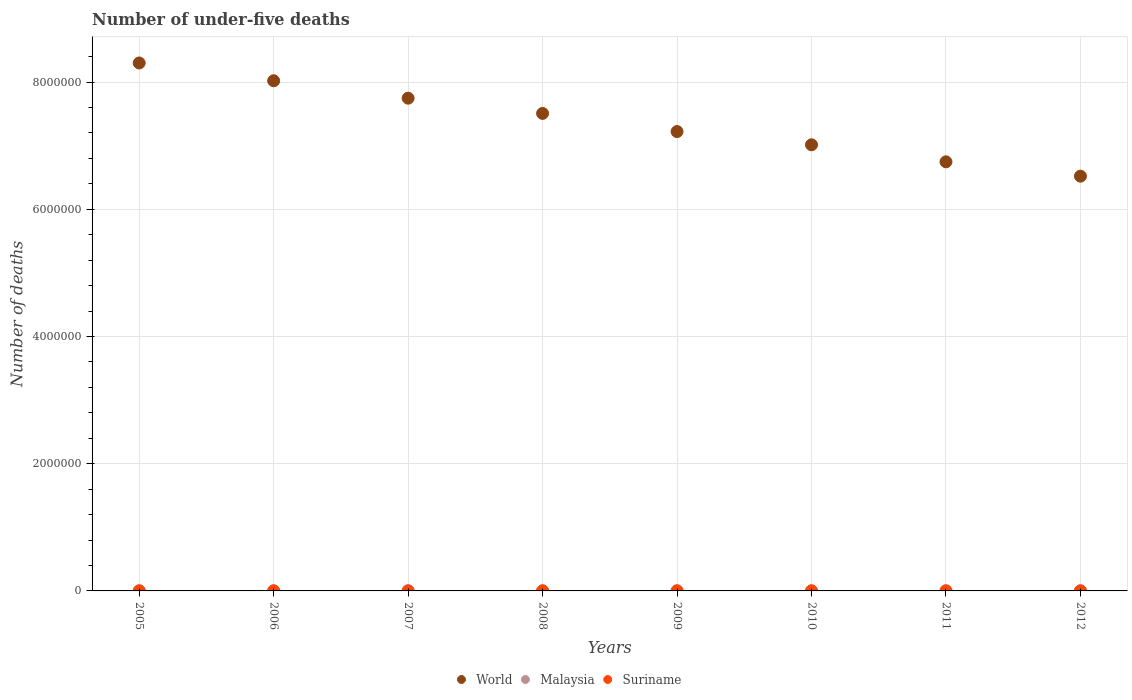Is the number of dotlines equal to the number of legend labels?
Your answer should be very brief. Yes. What is the number of under-five deaths in Suriname in 2006?
Provide a succinct answer. 278. Across all years, what is the maximum number of under-five deaths in Malaysia?
Your response must be concise. 4023. Across all years, what is the minimum number of under-five deaths in World?
Keep it short and to the point. 6.52e+06. In which year was the number of under-five deaths in Malaysia maximum?
Keep it short and to the point. 2005. In which year was the number of under-five deaths in Suriname minimum?
Provide a succinct answer. 2012. What is the total number of under-five deaths in World in the graph?
Your answer should be very brief. 5.91e+07. What is the difference between the number of under-five deaths in World in 2008 and that in 2009?
Provide a succinct answer. 2.85e+05. What is the difference between the number of under-five deaths in Malaysia in 2008 and the number of under-five deaths in Suriname in 2009?
Provide a succinct answer. 3275. What is the average number of under-five deaths in Malaysia per year?
Your answer should be very brief. 3645.88. In the year 2007, what is the difference between the number of under-five deaths in World and number of under-five deaths in Suriname?
Keep it short and to the point. 7.75e+06. What is the ratio of the number of under-five deaths in World in 2006 to that in 2011?
Your response must be concise. 1.19. Is the number of under-five deaths in Suriname in 2005 less than that in 2006?
Provide a succinct answer. No. What is the difference between the highest and the second highest number of under-five deaths in Malaysia?
Keep it short and to the point. 181. In how many years, is the number of under-five deaths in Suriname greater than the average number of under-five deaths in Suriname taken over all years?
Your response must be concise. 4. Is it the case that in every year, the sum of the number of under-five deaths in Suriname and number of under-five deaths in World  is greater than the number of under-five deaths in Malaysia?
Make the answer very short. Yes. Does the number of under-five deaths in Malaysia monotonically increase over the years?
Offer a very short reply. No. Is the number of under-five deaths in Malaysia strictly greater than the number of under-five deaths in World over the years?
Make the answer very short. No. Is the number of under-five deaths in World strictly less than the number of under-five deaths in Malaysia over the years?
Give a very brief answer. No. What is the difference between two consecutive major ticks on the Y-axis?
Make the answer very short. 2.00e+06. Are the values on the major ticks of Y-axis written in scientific E-notation?
Give a very brief answer. No. Does the graph contain any zero values?
Provide a short and direct response. No. Does the graph contain grids?
Your response must be concise. Yes. How are the legend labels stacked?
Your answer should be very brief. Horizontal. What is the title of the graph?
Keep it short and to the point. Number of under-five deaths. Does "Sint Maarten (Dutch part)" appear as one of the legend labels in the graph?
Your response must be concise. No. What is the label or title of the X-axis?
Your response must be concise. Years. What is the label or title of the Y-axis?
Provide a succinct answer. Number of deaths. What is the Number of deaths in World in 2005?
Make the answer very short. 8.30e+06. What is the Number of deaths in Malaysia in 2005?
Offer a terse response. 4023. What is the Number of deaths in Suriname in 2005?
Provide a short and direct response. 289. What is the Number of deaths in World in 2006?
Your response must be concise. 8.02e+06. What is the Number of deaths in Malaysia in 2006?
Give a very brief answer. 3842. What is the Number of deaths in Suriname in 2006?
Give a very brief answer. 278. What is the Number of deaths of World in 2007?
Make the answer very short. 7.75e+06. What is the Number of deaths of Malaysia in 2007?
Offer a terse response. 3651. What is the Number of deaths of Suriname in 2007?
Your response must be concise. 270. What is the Number of deaths in World in 2008?
Offer a terse response. 7.51e+06. What is the Number of deaths of Malaysia in 2008?
Offer a terse response. 3531. What is the Number of deaths in Suriname in 2008?
Offer a very short reply. 262. What is the Number of deaths of World in 2009?
Your answer should be very brief. 7.22e+06. What is the Number of deaths in Malaysia in 2009?
Your answer should be very brief. 3466. What is the Number of deaths of Suriname in 2009?
Offer a terse response. 256. What is the Number of deaths of World in 2010?
Give a very brief answer. 7.01e+06. What is the Number of deaths of Malaysia in 2010?
Provide a succinct answer. 3484. What is the Number of deaths in Suriname in 2010?
Keep it short and to the point. 251. What is the Number of deaths of World in 2011?
Give a very brief answer. 6.75e+06. What is the Number of deaths of Malaysia in 2011?
Make the answer very short. 3539. What is the Number of deaths of Suriname in 2011?
Your answer should be compact. 243. What is the Number of deaths of World in 2012?
Keep it short and to the point. 6.52e+06. What is the Number of deaths in Malaysia in 2012?
Provide a succinct answer. 3631. What is the Number of deaths of Suriname in 2012?
Your response must be concise. 235. Across all years, what is the maximum Number of deaths of World?
Your answer should be compact. 8.30e+06. Across all years, what is the maximum Number of deaths in Malaysia?
Offer a terse response. 4023. Across all years, what is the maximum Number of deaths of Suriname?
Your answer should be compact. 289. Across all years, what is the minimum Number of deaths in World?
Ensure brevity in your answer.  6.52e+06. Across all years, what is the minimum Number of deaths in Malaysia?
Keep it short and to the point. 3466. Across all years, what is the minimum Number of deaths in Suriname?
Make the answer very short. 235. What is the total Number of deaths in World in the graph?
Make the answer very short. 5.91e+07. What is the total Number of deaths of Malaysia in the graph?
Your response must be concise. 2.92e+04. What is the total Number of deaths of Suriname in the graph?
Provide a succinct answer. 2084. What is the difference between the Number of deaths in World in 2005 and that in 2006?
Provide a short and direct response. 2.80e+05. What is the difference between the Number of deaths in Malaysia in 2005 and that in 2006?
Your response must be concise. 181. What is the difference between the Number of deaths in World in 2005 and that in 2007?
Make the answer very short. 5.54e+05. What is the difference between the Number of deaths in Malaysia in 2005 and that in 2007?
Make the answer very short. 372. What is the difference between the Number of deaths of Suriname in 2005 and that in 2007?
Your answer should be compact. 19. What is the difference between the Number of deaths of World in 2005 and that in 2008?
Offer a very short reply. 7.93e+05. What is the difference between the Number of deaths of Malaysia in 2005 and that in 2008?
Your response must be concise. 492. What is the difference between the Number of deaths of Suriname in 2005 and that in 2008?
Your answer should be compact. 27. What is the difference between the Number of deaths in World in 2005 and that in 2009?
Ensure brevity in your answer.  1.08e+06. What is the difference between the Number of deaths of Malaysia in 2005 and that in 2009?
Give a very brief answer. 557. What is the difference between the Number of deaths of World in 2005 and that in 2010?
Provide a succinct answer. 1.29e+06. What is the difference between the Number of deaths of Malaysia in 2005 and that in 2010?
Your response must be concise. 539. What is the difference between the Number of deaths in Suriname in 2005 and that in 2010?
Make the answer very short. 38. What is the difference between the Number of deaths in World in 2005 and that in 2011?
Offer a terse response. 1.55e+06. What is the difference between the Number of deaths of Malaysia in 2005 and that in 2011?
Provide a succinct answer. 484. What is the difference between the Number of deaths in World in 2005 and that in 2012?
Your answer should be compact. 1.78e+06. What is the difference between the Number of deaths of Malaysia in 2005 and that in 2012?
Provide a succinct answer. 392. What is the difference between the Number of deaths in World in 2006 and that in 2007?
Your response must be concise. 2.74e+05. What is the difference between the Number of deaths of Malaysia in 2006 and that in 2007?
Ensure brevity in your answer.  191. What is the difference between the Number of deaths of Suriname in 2006 and that in 2007?
Your response must be concise. 8. What is the difference between the Number of deaths in World in 2006 and that in 2008?
Provide a short and direct response. 5.13e+05. What is the difference between the Number of deaths in Malaysia in 2006 and that in 2008?
Your answer should be compact. 311. What is the difference between the Number of deaths in World in 2006 and that in 2009?
Your answer should be very brief. 7.99e+05. What is the difference between the Number of deaths of Malaysia in 2006 and that in 2009?
Provide a short and direct response. 376. What is the difference between the Number of deaths of Suriname in 2006 and that in 2009?
Give a very brief answer. 22. What is the difference between the Number of deaths in World in 2006 and that in 2010?
Offer a very short reply. 1.01e+06. What is the difference between the Number of deaths in Malaysia in 2006 and that in 2010?
Ensure brevity in your answer.  358. What is the difference between the Number of deaths of World in 2006 and that in 2011?
Offer a very short reply. 1.27e+06. What is the difference between the Number of deaths in Malaysia in 2006 and that in 2011?
Provide a short and direct response. 303. What is the difference between the Number of deaths of Suriname in 2006 and that in 2011?
Keep it short and to the point. 35. What is the difference between the Number of deaths in World in 2006 and that in 2012?
Keep it short and to the point. 1.50e+06. What is the difference between the Number of deaths in Malaysia in 2006 and that in 2012?
Give a very brief answer. 211. What is the difference between the Number of deaths of World in 2007 and that in 2008?
Provide a succinct answer. 2.40e+05. What is the difference between the Number of deaths of Malaysia in 2007 and that in 2008?
Offer a very short reply. 120. What is the difference between the Number of deaths in World in 2007 and that in 2009?
Make the answer very short. 5.25e+05. What is the difference between the Number of deaths of Malaysia in 2007 and that in 2009?
Give a very brief answer. 185. What is the difference between the Number of deaths of Suriname in 2007 and that in 2009?
Your answer should be compact. 14. What is the difference between the Number of deaths in World in 2007 and that in 2010?
Your answer should be very brief. 7.33e+05. What is the difference between the Number of deaths of Malaysia in 2007 and that in 2010?
Your answer should be compact. 167. What is the difference between the Number of deaths in World in 2007 and that in 2011?
Offer a terse response. 1.00e+06. What is the difference between the Number of deaths of Malaysia in 2007 and that in 2011?
Ensure brevity in your answer.  112. What is the difference between the Number of deaths in World in 2007 and that in 2012?
Offer a terse response. 1.23e+06. What is the difference between the Number of deaths of World in 2008 and that in 2009?
Provide a succinct answer. 2.85e+05. What is the difference between the Number of deaths of Malaysia in 2008 and that in 2009?
Give a very brief answer. 65. What is the difference between the Number of deaths in World in 2008 and that in 2010?
Keep it short and to the point. 4.93e+05. What is the difference between the Number of deaths of World in 2008 and that in 2011?
Make the answer very short. 7.61e+05. What is the difference between the Number of deaths in Malaysia in 2008 and that in 2011?
Your response must be concise. -8. What is the difference between the Number of deaths of Suriname in 2008 and that in 2011?
Your answer should be compact. 19. What is the difference between the Number of deaths in World in 2008 and that in 2012?
Offer a terse response. 9.86e+05. What is the difference between the Number of deaths in Malaysia in 2008 and that in 2012?
Provide a short and direct response. -100. What is the difference between the Number of deaths of Suriname in 2008 and that in 2012?
Ensure brevity in your answer.  27. What is the difference between the Number of deaths of World in 2009 and that in 2010?
Your response must be concise. 2.08e+05. What is the difference between the Number of deaths in Malaysia in 2009 and that in 2010?
Provide a succinct answer. -18. What is the difference between the Number of deaths in World in 2009 and that in 2011?
Your answer should be very brief. 4.76e+05. What is the difference between the Number of deaths in Malaysia in 2009 and that in 2011?
Keep it short and to the point. -73. What is the difference between the Number of deaths in Suriname in 2009 and that in 2011?
Provide a short and direct response. 13. What is the difference between the Number of deaths of World in 2009 and that in 2012?
Offer a terse response. 7.01e+05. What is the difference between the Number of deaths of Malaysia in 2009 and that in 2012?
Offer a very short reply. -165. What is the difference between the Number of deaths in Suriname in 2009 and that in 2012?
Keep it short and to the point. 21. What is the difference between the Number of deaths in World in 2010 and that in 2011?
Your response must be concise. 2.68e+05. What is the difference between the Number of deaths of Malaysia in 2010 and that in 2011?
Give a very brief answer. -55. What is the difference between the Number of deaths of Suriname in 2010 and that in 2011?
Your answer should be very brief. 8. What is the difference between the Number of deaths of World in 2010 and that in 2012?
Offer a very short reply. 4.93e+05. What is the difference between the Number of deaths of Malaysia in 2010 and that in 2012?
Your answer should be compact. -147. What is the difference between the Number of deaths of World in 2011 and that in 2012?
Offer a terse response. 2.25e+05. What is the difference between the Number of deaths of Malaysia in 2011 and that in 2012?
Keep it short and to the point. -92. What is the difference between the Number of deaths of World in 2005 and the Number of deaths of Malaysia in 2006?
Keep it short and to the point. 8.30e+06. What is the difference between the Number of deaths in World in 2005 and the Number of deaths in Suriname in 2006?
Your answer should be compact. 8.30e+06. What is the difference between the Number of deaths in Malaysia in 2005 and the Number of deaths in Suriname in 2006?
Ensure brevity in your answer.  3745. What is the difference between the Number of deaths in World in 2005 and the Number of deaths in Malaysia in 2007?
Make the answer very short. 8.30e+06. What is the difference between the Number of deaths in World in 2005 and the Number of deaths in Suriname in 2007?
Give a very brief answer. 8.30e+06. What is the difference between the Number of deaths of Malaysia in 2005 and the Number of deaths of Suriname in 2007?
Your answer should be compact. 3753. What is the difference between the Number of deaths in World in 2005 and the Number of deaths in Malaysia in 2008?
Give a very brief answer. 8.30e+06. What is the difference between the Number of deaths in World in 2005 and the Number of deaths in Suriname in 2008?
Provide a succinct answer. 8.30e+06. What is the difference between the Number of deaths in Malaysia in 2005 and the Number of deaths in Suriname in 2008?
Provide a succinct answer. 3761. What is the difference between the Number of deaths of World in 2005 and the Number of deaths of Malaysia in 2009?
Make the answer very short. 8.30e+06. What is the difference between the Number of deaths of World in 2005 and the Number of deaths of Suriname in 2009?
Ensure brevity in your answer.  8.30e+06. What is the difference between the Number of deaths of Malaysia in 2005 and the Number of deaths of Suriname in 2009?
Offer a very short reply. 3767. What is the difference between the Number of deaths of World in 2005 and the Number of deaths of Malaysia in 2010?
Your response must be concise. 8.30e+06. What is the difference between the Number of deaths in World in 2005 and the Number of deaths in Suriname in 2010?
Your answer should be compact. 8.30e+06. What is the difference between the Number of deaths in Malaysia in 2005 and the Number of deaths in Suriname in 2010?
Your answer should be compact. 3772. What is the difference between the Number of deaths of World in 2005 and the Number of deaths of Malaysia in 2011?
Offer a terse response. 8.30e+06. What is the difference between the Number of deaths of World in 2005 and the Number of deaths of Suriname in 2011?
Ensure brevity in your answer.  8.30e+06. What is the difference between the Number of deaths of Malaysia in 2005 and the Number of deaths of Suriname in 2011?
Your response must be concise. 3780. What is the difference between the Number of deaths of World in 2005 and the Number of deaths of Malaysia in 2012?
Ensure brevity in your answer.  8.30e+06. What is the difference between the Number of deaths in World in 2005 and the Number of deaths in Suriname in 2012?
Make the answer very short. 8.30e+06. What is the difference between the Number of deaths in Malaysia in 2005 and the Number of deaths in Suriname in 2012?
Keep it short and to the point. 3788. What is the difference between the Number of deaths in World in 2006 and the Number of deaths in Malaysia in 2007?
Your answer should be compact. 8.02e+06. What is the difference between the Number of deaths in World in 2006 and the Number of deaths in Suriname in 2007?
Offer a very short reply. 8.02e+06. What is the difference between the Number of deaths in Malaysia in 2006 and the Number of deaths in Suriname in 2007?
Make the answer very short. 3572. What is the difference between the Number of deaths of World in 2006 and the Number of deaths of Malaysia in 2008?
Your answer should be very brief. 8.02e+06. What is the difference between the Number of deaths in World in 2006 and the Number of deaths in Suriname in 2008?
Give a very brief answer. 8.02e+06. What is the difference between the Number of deaths of Malaysia in 2006 and the Number of deaths of Suriname in 2008?
Your response must be concise. 3580. What is the difference between the Number of deaths in World in 2006 and the Number of deaths in Malaysia in 2009?
Offer a very short reply. 8.02e+06. What is the difference between the Number of deaths of World in 2006 and the Number of deaths of Suriname in 2009?
Your answer should be compact. 8.02e+06. What is the difference between the Number of deaths of Malaysia in 2006 and the Number of deaths of Suriname in 2009?
Make the answer very short. 3586. What is the difference between the Number of deaths of World in 2006 and the Number of deaths of Malaysia in 2010?
Provide a short and direct response. 8.02e+06. What is the difference between the Number of deaths of World in 2006 and the Number of deaths of Suriname in 2010?
Provide a short and direct response. 8.02e+06. What is the difference between the Number of deaths of Malaysia in 2006 and the Number of deaths of Suriname in 2010?
Your response must be concise. 3591. What is the difference between the Number of deaths of World in 2006 and the Number of deaths of Malaysia in 2011?
Make the answer very short. 8.02e+06. What is the difference between the Number of deaths of World in 2006 and the Number of deaths of Suriname in 2011?
Your answer should be very brief. 8.02e+06. What is the difference between the Number of deaths in Malaysia in 2006 and the Number of deaths in Suriname in 2011?
Your answer should be compact. 3599. What is the difference between the Number of deaths in World in 2006 and the Number of deaths in Malaysia in 2012?
Offer a terse response. 8.02e+06. What is the difference between the Number of deaths of World in 2006 and the Number of deaths of Suriname in 2012?
Your response must be concise. 8.02e+06. What is the difference between the Number of deaths of Malaysia in 2006 and the Number of deaths of Suriname in 2012?
Your answer should be compact. 3607. What is the difference between the Number of deaths of World in 2007 and the Number of deaths of Malaysia in 2008?
Your response must be concise. 7.74e+06. What is the difference between the Number of deaths in World in 2007 and the Number of deaths in Suriname in 2008?
Your answer should be very brief. 7.75e+06. What is the difference between the Number of deaths in Malaysia in 2007 and the Number of deaths in Suriname in 2008?
Your response must be concise. 3389. What is the difference between the Number of deaths of World in 2007 and the Number of deaths of Malaysia in 2009?
Ensure brevity in your answer.  7.74e+06. What is the difference between the Number of deaths of World in 2007 and the Number of deaths of Suriname in 2009?
Your answer should be very brief. 7.75e+06. What is the difference between the Number of deaths of Malaysia in 2007 and the Number of deaths of Suriname in 2009?
Offer a terse response. 3395. What is the difference between the Number of deaths of World in 2007 and the Number of deaths of Malaysia in 2010?
Provide a succinct answer. 7.74e+06. What is the difference between the Number of deaths in World in 2007 and the Number of deaths in Suriname in 2010?
Your answer should be compact. 7.75e+06. What is the difference between the Number of deaths in Malaysia in 2007 and the Number of deaths in Suriname in 2010?
Make the answer very short. 3400. What is the difference between the Number of deaths in World in 2007 and the Number of deaths in Malaysia in 2011?
Your answer should be compact. 7.74e+06. What is the difference between the Number of deaths in World in 2007 and the Number of deaths in Suriname in 2011?
Give a very brief answer. 7.75e+06. What is the difference between the Number of deaths in Malaysia in 2007 and the Number of deaths in Suriname in 2011?
Give a very brief answer. 3408. What is the difference between the Number of deaths of World in 2007 and the Number of deaths of Malaysia in 2012?
Your answer should be very brief. 7.74e+06. What is the difference between the Number of deaths in World in 2007 and the Number of deaths in Suriname in 2012?
Keep it short and to the point. 7.75e+06. What is the difference between the Number of deaths of Malaysia in 2007 and the Number of deaths of Suriname in 2012?
Give a very brief answer. 3416. What is the difference between the Number of deaths of World in 2008 and the Number of deaths of Malaysia in 2009?
Offer a very short reply. 7.50e+06. What is the difference between the Number of deaths of World in 2008 and the Number of deaths of Suriname in 2009?
Your response must be concise. 7.51e+06. What is the difference between the Number of deaths of Malaysia in 2008 and the Number of deaths of Suriname in 2009?
Your answer should be compact. 3275. What is the difference between the Number of deaths in World in 2008 and the Number of deaths in Malaysia in 2010?
Make the answer very short. 7.50e+06. What is the difference between the Number of deaths of World in 2008 and the Number of deaths of Suriname in 2010?
Your response must be concise. 7.51e+06. What is the difference between the Number of deaths of Malaysia in 2008 and the Number of deaths of Suriname in 2010?
Make the answer very short. 3280. What is the difference between the Number of deaths in World in 2008 and the Number of deaths in Malaysia in 2011?
Make the answer very short. 7.50e+06. What is the difference between the Number of deaths of World in 2008 and the Number of deaths of Suriname in 2011?
Give a very brief answer. 7.51e+06. What is the difference between the Number of deaths in Malaysia in 2008 and the Number of deaths in Suriname in 2011?
Provide a succinct answer. 3288. What is the difference between the Number of deaths of World in 2008 and the Number of deaths of Malaysia in 2012?
Your response must be concise. 7.50e+06. What is the difference between the Number of deaths in World in 2008 and the Number of deaths in Suriname in 2012?
Your answer should be very brief. 7.51e+06. What is the difference between the Number of deaths in Malaysia in 2008 and the Number of deaths in Suriname in 2012?
Offer a very short reply. 3296. What is the difference between the Number of deaths in World in 2009 and the Number of deaths in Malaysia in 2010?
Give a very brief answer. 7.22e+06. What is the difference between the Number of deaths of World in 2009 and the Number of deaths of Suriname in 2010?
Your answer should be compact. 7.22e+06. What is the difference between the Number of deaths in Malaysia in 2009 and the Number of deaths in Suriname in 2010?
Offer a terse response. 3215. What is the difference between the Number of deaths of World in 2009 and the Number of deaths of Malaysia in 2011?
Keep it short and to the point. 7.22e+06. What is the difference between the Number of deaths of World in 2009 and the Number of deaths of Suriname in 2011?
Keep it short and to the point. 7.22e+06. What is the difference between the Number of deaths of Malaysia in 2009 and the Number of deaths of Suriname in 2011?
Your answer should be compact. 3223. What is the difference between the Number of deaths of World in 2009 and the Number of deaths of Malaysia in 2012?
Offer a terse response. 7.22e+06. What is the difference between the Number of deaths in World in 2009 and the Number of deaths in Suriname in 2012?
Provide a short and direct response. 7.22e+06. What is the difference between the Number of deaths in Malaysia in 2009 and the Number of deaths in Suriname in 2012?
Offer a very short reply. 3231. What is the difference between the Number of deaths in World in 2010 and the Number of deaths in Malaysia in 2011?
Make the answer very short. 7.01e+06. What is the difference between the Number of deaths of World in 2010 and the Number of deaths of Suriname in 2011?
Provide a succinct answer. 7.01e+06. What is the difference between the Number of deaths in Malaysia in 2010 and the Number of deaths in Suriname in 2011?
Offer a very short reply. 3241. What is the difference between the Number of deaths in World in 2010 and the Number of deaths in Malaysia in 2012?
Offer a terse response. 7.01e+06. What is the difference between the Number of deaths in World in 2010 and the Number of deaths in Suriname in 2012?
Ensure brevity in your answer.  7.01e+06. What is the difference between the Number of deaths in Malaysia in 2010 and the Number of deaths in Suriname in 2012?
Provide a short and direct response. 3249. What is the difference between the Number of deaths in World in 2011 and the Number of deaths in Malaysia in 2012?
Provide a succinct answer. 6.74e+06. What is the difference between the Number of deaths in World in 2011 and the Number of deaths in Suriname in 2012?
Give a very brief answer. 6.75e+06. What is the difference between the Number of deaths in Malaysia in 2011 and the Number of deaths in Suriname in 2012?
Keep it short and to the point. 3304. What is the average Number of deaths in World per year?
Provide a short and direct response. 7.38e+06. What is the average Number of deaths in Malaysia per year?
Provide a succinct answer. 3645.88. What is the average Number of deaths in Suriname per year?
Provide a succinct answer. 260.5. In the year 2005, what is the difference between the Number of deaths of World and Number of deaths of Malaysia?
Provide a succinct answer. 8.30e+06. In the year 2005, what is the difference between the Number of deaths in World and Number of deaths in Suriname?
Provide a short and direct response. 8.30e+06. In the year 2005, what is the difference between the Number of deaths of Malaysia and Number of deaths of Suriname?
Your answer should be compact. 3734. In the year 2006, what is the difference between the Number of deaths in World and Number of deaths in Malaysia?
Your answer should be very brief. 8.02e+06. In the year 2006, what is the difference between the Number of deaths in World and Number of deaths in Suriname?
Your answer should be very brief. 8.02e+06. In the year 2006, what is the difference between the Number of deaths of Malaysia and Number of deaths of Suriname?
Give a very brief answer. 3564. In the year 2007, what is the difference between the Number of deaths of World and Number of deaths of Malaysia?
Offer a very short reply. 7.74e+06. In the year 2007, what is the difference between the Number of deaths of World and Number of deaths of Suriname?
Give a very brief answer. 7.75e+06. In the year 2007, what is the difference between the Number of deaths of Malaysia and Number of deaths of Suriname?
Keep it short and to the point. 3381. In the year 2008, what is the difference between the Number of deaths in World and Number of deaths in Malaysia?
Offer a terse response. 7.50e+06. In the year 2008, what is the difference between the Number of deaths in World and Number of deaths in Suriname?
Give a very brief answer. 7.51e+06. In the year 2008, what is the difference between the Number of deaths of Malaysia and Number of deaths of Suriname?
Offer a terse response. 3269. In the year 2009, what is the difference between the Number of deaths in World and Number of deaths in Malaysia?
Your answer should be compact. 7.22e+06. In the year 2009, what is the difference between the Number of deaths of World and Number of deaths of Suriname?
Keep it short and to the point. 7.22e+06. In the year 2009, what is the difference between the Number of deaths in Malaysia and Number of deaths in Suriname?
Make the answer very short. 3210. In the year 2010, what is the difference between the Number of deaths of World and Number of deaths of Malaysia?
Offer a terse response. 7.01e+06. In the year 2010, what is the difference between the Number of deaths in World and Number of deaths in Suriname?
Give a very brief answer. 7.01e+06. In the year 2010, what is the difference between the Number of deaths in Malaysia and Number of deaths in Suriname?
Give a very brief answer. 3233. In the year 2011, what is the difference between the Number of deaths in World and Number of deaths in Malaysia?
Keep it short and to the point. 6.74e+06. In the year 2011, what is the difference between the Number of deaths in World and Number of deaths in Suriname?
Keep it short and to the point. 6.75e+06. In the year 2011, what is the difference between the Number of deaths in Malaysia and Number of deaths in Suriname?
Make the answer very short. 3296. In the year 2012, what is the difference between the Number of deaths of World and Number of deaths of Malaysia?
Keep it short and to the point. 6.52e+06. In the year 2012, what is the difference between the Number of deaths of World and Number of deaths of Suriname?
Keep it short and to the point. 6.52e+06. In the year 2012, what is the difference between the Number of deaths in Malaysia and Number of deaths in Suriname?
Offer a very short reply. 3396. What is the ratio of the Number of deaths in World in 2005 to that in 2006?
Ensure brevity in your answer.  1.03. What is the ratio of the Number of deaths of Malaysia in 2005 to that in 2006?
Make the answer very short. 1.05. What is the ratio of the Number of deaths in Suriname in 2005 to that in 2006?
Keep it short and to the point. 1.04. What is the ratio of the Number of deaths of World in 2005 to that in 2007?
Offer a very short reply. 1.07. What is the ratio of the Number of deaths of Malaysia in 2005 to that in 2007?
Your response must be concise. 1.1. What is the ratio of the Number of deaths in Suriname in 2005 to that in 2007?
Your answer should be compact. 1.07. What is the ratio of the Number of deaths in World in 2005 to that in 2008?
Keep it short and to the point. 1.11. What is the ratio of the Number of deaths in Malaysia in 2005 to that in 2008?
Give a very brief answer. 1.14. What is the ratio of the Number of deaths of Suriname in 2005 to that in 2008?
Ensure brevity in your answer.  1.1. What is the ratio of the Number of deaths in World in 2005 to that in 2009?
Ensure brevity in your answer.  1.15. What is the ratio of the Number of deaths in Malaysia in 2005 to that in 2009?
Keep it short and to the point. 1.16. What is the ratio of the Number of deaths in Suriname in 2005 to that in 2009?
Provide a succinct answer. 1.13. What is the ratio of the Number of deaths in World in 2005 to that in 2010?
Your answer should be compact. 1.18. What is the ratio of the Number of deaths of Malaysia in 2005 to that in 2010?
Keep it short and to the point. 1.15. What is the ratio of the Number of deaths in Suriname in 2005 to that in 2010?
Offer a very short reply. 1.15. What is the ratio of the Number of deaths in World in 2005 to that in 2011?
Give a very brief answer. 1.23. What is the ratio of the Number of deaths of Malaysia in 2005 to that in 2011?
Provide a short and direct response. 1.14. What is the ratio of the Number of deaths of Suriname in 2005 to that in 2011?
Keep it short and to the point. 1.19. What is the ratio of the Number of deaths of World in 2005 to that in 2012?
Offer a very short reply. 1.27. What is the ratio of the Number of deaths of Malaysia in 2005 to that in 2012?
Give a very brief answer. 1.11. What is the ratio of the Number of deaths of Suriname in 2005 to that in 2012?
Give a very brief answer. 1.23. What is the ratio of the Number of deaths of World in 2006 to that in 2007?
Ensure brevity in your answer.  1.04. What is the ratio of the Number of deaths in Malaysia in 2006 to that in 2007?
Provide a short and direct response. 1.05. What is the ratio of the Number of deaths of Suriname in 2006 to that in 2007?
Give a very brief answer. 1.03. What is the ratio of the Number of deaths of World in 2006 to that in 2008?
Your answer should be very brief. 1.07. What is the ratio of the Number of deaths of Malaysia in 2006 to that in 2008?
Offer a terse response. 1.09. What is the ratio of the Number of deaths of Suriname in 2006 to that in 2008?
Your response must be concise. 1.06. What is the ratio of the Number of deaths of World in 2006 to that in 2009?
Offer a terse response. 1.11. What is the ratio of the Number of deaths in Malaysia in 2006 to that in 2009?
Your answer should be compact. 1.11. What is the ratio of the Number of deaths in Suriname in 2006 to that in 2009?
Keep it short and to the point. 1.09. What is the ratio of the Number of deaths in World in 2006 to that in 2010?
Offer a terse response. 1.14. What is the ratio of the Number of deaths of Malaysia in 2006 to that in 2010?
Your answer should be very brief. 1.1. What is the ratio of the Number of deaths of Suriname in 2006 to that in 2010?
Your answer should be compact. 1.11. What is the ratio of the Number of deaths in World in 2006 to that in 2011?
Your response must be concise. 1.19. What is the ratio of the Number of deaths of Malaysia in 2006 to that in 2011?
Offer a terse response. 1.09. What is the ratio of the Number of deaths in Suriname in 2006 to that in 2011?
Ensure brevity in your answer.  1.14. What is the ratio of the Number of deaths of World in 2006 to that in 2012?
Make the answer very short. 1.23. What is the ratio of the Number of deaths of Malaysia in 2006 to that in 2012?
Your response must be concise. 1.06. What is the ratio of the Number of deaths of Suriname in 2006 to that in 2012?
Your answer should be very brief. 1.18. What is the ratio of the Number of deaths of World in 2007 to that in 2008?
Provide a short and direct response. 1.03. What is the ratio of the Number of deaths in Malaysia in 2007 to that in 2008?
Your response must be concise. 1.03. What is the ratio of the Number of deaths in Suriname in 2007 to that in 2008?
Ensure brevity in your answer.  1.03. What is the ratio of the Number of deaths of World in 2007 to that in 2009?
Ensure brevity in your answer.  1.07. What is the ratio of the Number of deaths of Malaysia in 2007 to that in 2009?
Give a very brief answer. 1.05. What is the ratio of the Number of deaths of Suriname in 2007 to that in 2009?
Give a very brief answer. 1.05. What is the ratio of the Number of deaths of World in 2007 to that in 2010?
Make the answer very short. 1.1. What is the ratio of the Number of deaths in Malaysia in 2007 to that in 2010?
Ensure brevity in your answer.  1.05. What is the ratio of the Number of deaths of Suriname in 2007 to that in 2010?
Give a very brief answer. 1.08. What is the ratio of the Number of deaths of World in 2007 to that in 2011?
Offer a terse response. 1.15. What is the ratio of the Number of deaths in Malaysia in 2007 to that in 2011?
Give a very brief answer. 1.03. What is the ratio of the Number of deaths of Suriname in 2007 to that in 2011?
Your answer should be very brief. 1.11. What is the ratio of the Number of deaths in World in 2007 to that in 2012?
Provide a short and direct response. 1.19. What is the ratio of the Number of deaths of Malaysia in 2007 to that in 2012?
Make the answer very short. 1.01. What is the ratio of the Number of deaths in Suriname in 2007 to that in 2012?
Provide a short and direct response. 1.15. What is the ratio of the Number of deaths in World in 2008 to that in 2009?
Your answer should be compact. 1.04. What is the ratio of the Number of deaths of Malaysia in 2008 to that in 2009?
Provide a short and direct response. 1.02. What is the ratio of the Number of deaths in Suriname in 2008 to that in 2009?
Offer a very short reply. 1.02. What is the ratio of the Number of deaths of World in 2008 to that in 2010?
Provide a succinct answer. 1.07. What is the ratio of the Number of deaths of Malaysia in 2008 to that in 2010?
Provide a succinct answer. 1.01. What is the ratio of the Number of deaths in Suriname in 2008 to that in 2010?
Give a very brief answer. 1.04. What is the ratio of the Number of deaths of World in 2008 to that in 2011?
Give a very brief answer. 1.11. What is the ratio of the Number of deaths in Suriname in 2008 to that in 2011?
Provide a succinct answer. 1.08. What is the ratio of the Number of deaths of World in 2008 to that in 2012?
Your answer should be compact. 1.15. What is the ratio of the Number of deaths of Malaysia in 2008 to that in 2012?
Make the answer very short. 0.97. What is the ratio of the Number of deaths in Suriname in 2008 to that in 2012?
Keep it short and to the point. 1.11. What is the ratio of the Number of deaths in World in 2009 to that in 2010?
Offer a very short reply. 1.03. What is the ratio of the Number of deaths in Suriname in 2009 to that in 2010?
Make the answer very short. 1.02. What is the ratio of the Number of deaths in World in 2009 to that in 2011?
Give a very brief answer. 1.07. What is the ratio of the Number of deaths of Malaysia in 2009 to that in 2011?
Your answer should be very brief. 0.98. What is the ratio of the Number of deaths in Suriname in 2009 to that in 2011?
Your answer should be very brief. 1.05. What is the ratio of the Number of deaths in World in 2009 to that in 2012?
Offer a very short reply. 1.11. What is the ratio of the Number of deaths in Malaysia in 2009 to that in 2012?
Offer a very short reply. 0.95. What is the ratio of the Number of deaths of Suriname in 2009 to that in 2012?
Your answer should be compact. 1.09. What is the ratio of the Number of deaths of World in 2010 to that in 2011?
Your answer should be compact. 1.04. What is the ratio of the Number of deaths of Malaysia in 2010 to that in 2011?
Offer a very short reply. 0.98. What is the ratio of the Number of deaths of Suriname in 2010 to that in 2011?
Offer a very short reply. 1.03. What is the ratio of the Number of deaths of World in 2010 to that in 2012?
Make the answer very short. 1.08. What is the ratio of the Number of deaths of Malaysia in 2010 to that in 2012?
Your answer should be compact. 0.96. What is the ratio of the Number of deaths of Suriname in 2010 to that in 2012?
Provide a succinct answer. 1.07. What is the ratio of the Number of deaths in World in 2011 to that in 2012?
Keep it short and to the point. 1.03. What is the ratio of the Number of deaths in Malaysia in 2011 to that in 2012?
Your answer should be very brief. 0.97. What is the ratio of the Number of deaths in Suriname in 2011 to that in 2012?
Provide a succinct answer. 1.03. What is the difference between the highest and the second highest Number of deaths of World?
Your response must be concise. 2.80e+05. What is the difference between the highest and the second highest Number of deaths of Malaysia?
Give a very brief answer. 181. What is the difference between the highest and the second highest Number of deaths in Suriname?
Give a very brief answer. 11. What is the difference between the highest and the lowest Number of deaths in World?
Offer a terse response. 1.78e+06. What is the difference between the highest and the lowest Number of deaths in Malaysia?
Your answer should be very brief. 557. 